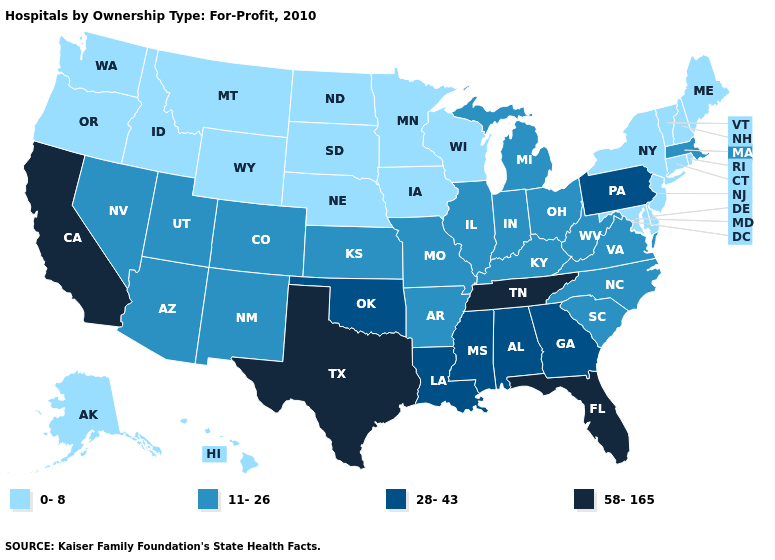Name the states that have a value in the range 28-43?
Be succinct. Alabama, Georgia, Louisiana, Mississippi, Oklahoma, Pennsylvania. What is the value of Idaho?
Give a very brief answer. 0-8. Does Oregon have the same value as Maine?
Write a very short answer. Yes. Which states have the lowest value in the USA?
Short answer required. Alaska, Connecticut, Delaware, Hawaii, Idaho, Iowa, Maine, Maryland, Minnesota, Montana, Nebraska, New Hampshire, New Jersey, New York, North Dakota, Oregon, Rhode Island, South Dakota, Vermont, Washington, Wisconsin, Wyoming. Among the states that border Alabama , which have the lowest value?
Write a very short answer. Georgia, Mississippi. Which states have the highest value in the USA?
Answer briefly. California, Florida, Tennessee, Texas. Which states have the lowest value in the USA?
Keep it brief. Alaska, Connecticut, Delaware, Hawaii, Idaho, Iowa, Maine, Maryland, Minnesota, Montana, Nebraska, New Hampshire, New Jersey, New York, North Dakota, Oregon, Rhode Island, South Dakota, Vermont, Washington, Wisconsin, Wyoming. What is the highest value in the USA?
Answer briefly. 58-165. What is the value of Washington?
Answer briefly. 0-8. What is the lowest value in states that border Ohio?
Write a very short answer. 11-26. Among the states that border Utah , does Colorado have the highest value?
Write a very short answer. Yes. Name the states that have a value in the range 11-26?
Answer briefly. Arizona, Arkansas, Colorado, Illinois, Indiana, Kansas, Kentucky, Massachusetts, Michigan, Missouri, Nevada, New Mexico, North Carolina, Ohio, South Carolina, Utah, Virginia, West Virginia. What is the value of Missouri?
Answer briefly. 11-26. What is the value of Kansas?
Short answer required. 11-26. What is the lowest value in the South?
Give a very brief answer. 0-8. 